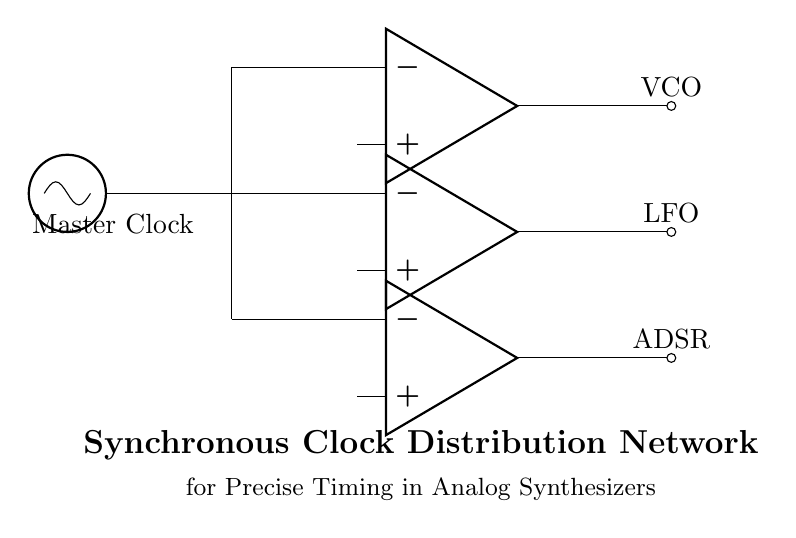What type of clock source is used in this circuit? The circuit diagram shows a "Master Clock" as the main clock source, which is often used to provide the timing reference for other components.
Answer: Master Clock How many buffer amplifiers are present in this circuit? The diagram indicates three buffer amplifiers branching off from the main clock source, suggesting that there are three instances of signal amplification occurring for distribution.
Answer: Three What components are connected to the clock outputs? The outputs of the three buffer amplifiers connect to "VCO," "LFO," and "ADSR," which are typical modules in an analog synthesizer that require clock signals for precise timing.
Answer: VCO, LFO, ADSR Why are buffers used in this clock distribution network? Buffers are used to prevent signal degradation and to provide isolation between the main clock source and various synthesizer modules, ensuring that each module receives a strong and clean clock signal without interference.
Answer: Signal integrity What direction does the clock signal flow from the master clock? The clock signal flows horizontally to the right from the Master Clock through the distribution path to the buffers and then out to the synthesizer modules.
Answer: Right Which component type is used for output connections in this network? The output connections in the circuit are indicated by "ocirc" symbols, which denote output nodes connecting to other devices, indicating where the clock signals exit the distribution network.
Answer: Output nodes What is the primary function of the synchronous clock distribution network? The primary function is to ensure precise timing across different synthesizer modules to maintain synchronization and enhance the performance of the analog synthesizer.
Answer: Precise timing 